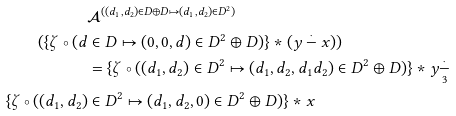<formula> <loc_0><loc_0><loc_500><loc_500>& \mathcal { A } ^ { ( ( d _ { 1 } , d _ { 2 } ) \in D \oplus D \mapsto ( d _ { 1 } , d _ { 2 } ) \in D ^ { 2 } ) } \\ ( \{ \zeta \circ ( d & \in D \mapsto ( 0 , 0 , d ) \in D ^ { 2 } \oplus D ) \} \ast ( y \overset { \cdot } { - } x ) ) \\ & = \{ \zeta \circ ( ( d _ { 1 } , d _ { 2 } ) \in D ^ { 2 } \mapsto ( d _ { 1 } , d _ { 2 } , d _ { 1 } d _ { 2 } ) \in D ^ { 2 } \oplus D ) \} \ast y \underset { 3 } { \overset { \cdot } { - } } \\ \{ \zeta \circ ( ( d _ { 1 } , d _ { 2 } ) & \in D ^ { 2 } \mapsto ( d _ { 1 } , d _ { 2 } , 0 ) \in D ^ { 2 } \oplus D ) \} \ast x</formula> 